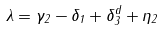<formula> <loc_0><loc_0><loc_500><loc_500>\lambda = \gamma _ { 2 } - \delta _ { 1 } + \delta ^ { d } _ { 3 } + \eta _ { 2 }</formula> 